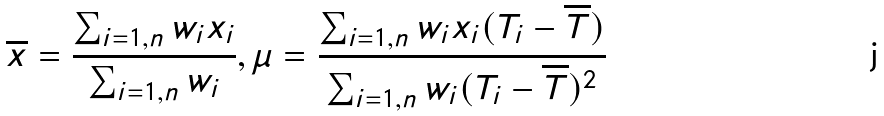Convert formula to latex. <formula><loc_0><loc_0><loc_500><loc_500>\overline { x } = \frac { \sum _ { i = 1 , n } w _ { i } x _ { i } } { \sum _ { i = 1 , n } w _ { i } } , \mu = \frac { \sum _ { i = 1 , n } w _ { i } x _ { i } ( T _ { i } - \overline { T } ) } { \sum _ { i = 1 , n } w _ { i } ( T _ { i } - \overline { T } ) ^ { 2 } }</formula> 